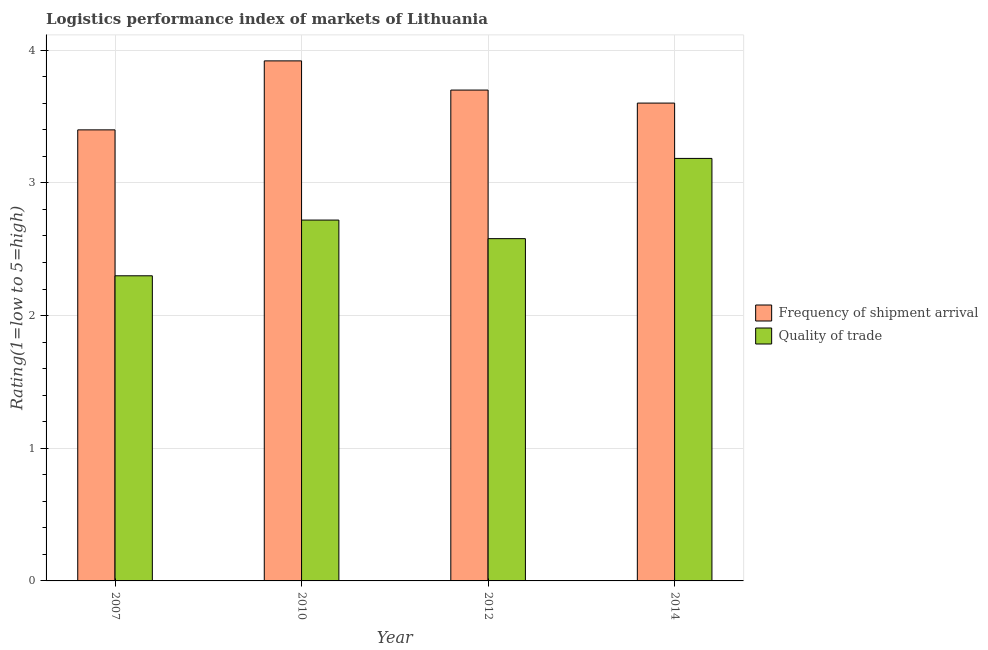How many different coloured bars are there?
Your response must be concise. 2. Are the number of bars per tick equal to the number of legend labels?
Give a very brief answer. Yes. Are the number of bars on each tick of the X-axis equal?
Offer a terse response. Yes. How many bars are there on the 1st tick from the left?
Offer a very short reply. 2. In how many cases, is the number of bars for a given year not equal to the number of legend labels?
Give a very brief answer. 0. What is the lpi of frequency of shipment arrival in 2012?
Your answer should be very brief. 3.7. Across all years, what is the maximum lpi of frequency of shipment arrival?
Keep it short and to the point. 3.92. Across all years, what is the minimum lpi of frequency of shipment arrival?
Your response must be concise. 3.4. In which year was the lpi quality of trade maximum?
Provide a short and direct response. 2014. In which year was the lpi of frequency of shipment arrival minimum?
Keep it short and to the point. 2007. What is the total lpi of frequency of shipment arrival in the graph?
Make the answer very short. 14.62. What is the difference between the lpi quality of trade in 2010 and that in 2012?
Keep it short and to the point. 0.14. What is the difference between the lpi of frequency of shipment arrival in 2014 and the lpi quality of trade in 2007?
Your response must be concise. 0.2. What is the average lpi of frequency of shipment arrival per year?
Your answer should be compact. 3.66. What is the ratio of the lpi quality of trade in 2007 to that in 2010?
Your answer should be compact. 0.85. Is the lpi quality of trade in 2010 less than that in 2012?
Ensure brevity in your answer.  No. What is the difference between the highest and the second highest lpi of frequency of shipment arrival?
Give a very brief answer. 0.22. What is the difference between the highest and the lowest lpi of frequency of shipment arrival?
Keep it short and to the point. 0.52. In how many years, is the lpi of frequency of shipment arrival greater than the average lpi of frequency of shipment arrival taken over all years?
Ensure brevity in your answer.  2. Is the sum of the lpi quality of trade in 2012 and 2014 greater than the maximum lpi of frequency of shipment arrival across all years?
Provide a succinct answer. Yes. What does the 1st bar from the left in 2012 represents?
Provide a succinct answer. Frequency of shipment arrival. What does the 1st bar from the right in 2007 represents?
Ensure brevity in your answer.  Quality of trade. Are all the bars in the graph horizontal?
Your answer should be very brief. No. How many years are there in the graph?
Offer a very short reply. 4. What is the difference between two consecutive major ticks on the Y-axis?
Offer a very short reply. 1. Are the values on the major ticks of Y-axis written in scientific E-notation?
Ensure brevity in your answer.  No. Does the graph contain grids?
Ensure brevity in your answer.  Yes. What is the title of the graph?
Provide a short and direct response. Logistics performance index of markets of Lithuania. What is the label or title of the Y-axis?
Offer a very short reply. Rating(1=low to 5=high). What is the Rating(1=low to 5=high) in Quality of trade in 2007?
Keep it short and to the point. 2.3. What is the Rating(1=low to 5=high) of Frequency of shipment arrival in 2010?
Your answer should be very brief. 3.92. What is the Rating(1=low to 5=high) in Quality of trade in 2010?
Give a very brief answer. 2.72. What is the Rating(1=low to 5=high) in Frequency of shipment arrival in 2012?
Your answer should be very brief. 3.7. What is the Rating(1=low to 5=high) in Quality of trade in 2012?
Offer a very short reply. 2.58. What is the Rating(1=low to 5=high) of Frequency of shipment arrival in 2014?
Give a very brief answer. 3.6. What is the Rating(1=low to 5=high) of Quality of trade in 2014?
Give a very brief answer. 3.18. Across all years, what is the maximum Rating(1=low to 5=high) of Frequency of shipment arrival?
Provide a succinct answer. 3.92. Across all years, what is the maximum Rating(1=low to 5=high) of Quality of trade?
Keep it short and to the point. 3.18. What is the total Rating(1=low to 5=high) of Frequency of shipment arrival in the graph?
Your answer should be very brief. 14.62. What is the total Rating(1=low to 5=high) in Quality of trade in the graph?
Your answer should be compact. 10.78. What is the difference between the Rating(1=low to 5=high) in Frequency of shipment arrival in 2007 and that in 2010?
Provide a short and direct response. -0.52. What is the difference between the Rating(1=low to 5=high) of Quality of trade in 2007 and that in 2010?
Your response must be concise. -0.42. What is the difference between the Rating(1=low to 5=high) of Frequency of shipment arrival in 2007 and that in 2012?
Make the answer very short. -0.3. What is the difference between the Rating(1=low to 5=high) of Quality of trade in 2007 and that in 2012?
Keep it short and to the point. -0.28. What is the difference between the Rating(1=low to 5=high) of Frequency of shipment arrival in 2007 and that in 2014?
Your answer should be very brief. -0.2. What is the difference between the Rating(1=low to 5=high) of Quality of trade in 2007 and that in 2014?
Make the answer very short. -0.88. What is the difference between the Rating(1=low to 5=high) of Frequency of shipment arrival in 2010 and that in 2012?
Ensure brevity in your answer.  0.22. What is the difference between the Rating(1=low to 5=high) of Quality of trade in 2010 and that in 2012?
Provide a short and direct response. 0.14. What is the difference between the Rating(1=low to 5=high) of Frequency of shipment arrival in 2010 and that in 2014?
Offer a terse response. 0.32. What is the difference between the Rating(1=low to 5=high) of Quality of trade in 2010 and that in 2014?
Give a very brief answer. -0.46. What is the difference between the Rating(1=low to 5=high) of Frequency of shipment arrival in 2012 and that in 2014?
Offer a very short reply. 0.1. What is the difference between the Rating(1=low to 5=high) of Quality of trade in 2012 and that in 2014?
Give a very brief answer. -0.6. What is the difference between the Rating(1=low to 5=high) of Frequency of shipment arrival in 2007 and the Rating(1=low to 5=high) of Quality of trade in 2010?
Your answer should be very brief. 0.68. What is the difference between the Rating(1=low to 5=high) in Frequency of shipment arrival in 2007 and the Rating(1=low to 5=high) in Quality of trade in 2012?
Keep it short and to the point. 0.82. What is the difference between the Rating(1=low to 5=high) in Frequency of shipment arrival in 2007 and the Rating(1=low to 5=high) in Quality of trade in 2014?
Provide a short and direct response. 0.22. What is the difference between the Rating(1=low to 5=high) of Frequency of shipment arrival in 2010 and the Rating(1=low to 5=high) of Quality of trade in 2012?
Provide a succinct answer. 1.34. What is the difference between the Rating(1=low to 5=high) in Frequency of shipment arrival in 2010 and the Rating(1=low to 5=high) in Quality of trade in 2014?
Provide a succinct answer. 0.74. What is the difference between the Rating(1=low to 5=high) of Frequency of shipment arrival in 2012 and the Rating(1=low to 5=high) of Quality of trade in 2014?
Your answer should be very brief. 0.52. What is the average Rating(1=low to 5=high) in Frequency of shipment arrival per year?
Keep it short and to the point. 3.66. What is the average Rating(1=low to 5=high) of Quality of trade per year?
Offer a terse response. 2.7. In the year 2007, what is the difference between the Rating(1=low to 5=high) of Frequency of shipment arrival and Rating(1=low to 5=high) of Quality of trade?
Your answer should be very brief. 1.1. In the year 2012, what is the difference between the Rating(1=low to 5=high) in Frequency of shipment arrival and Rating(1=low to 5=high) in Quality of trade?
Provide a succinct answer. 1.12. In the year 2014, what is the difference between the Rating(1=low to 5=high) in Frequency of shipment arrival and Rating(1=low to 5=high) in Quality of trade?
Your response must be concise. 0.42. What is the ratio of the Rating(1=low to 5=high) in Frequency of shipment arrival in 2007 to that in 2010?
Give a very brief answer. 0.87. What is the ratio of the Rating(1=low to 5=high) in Quality of trade in 2007 to that in 2010?
Keep it short and to the point. 0.85. What is the ratio of the Rating(1=low to 5=high) of Frequency of shipment arrival in 2007 to that in 2012?
Your answer should be compact. 0.92. What is the ratio of the Rating(1=low to 5=high) of Quality of trade in 2007 to that in 2012?
Offer a very short reply. 0.89. What is the ratio of the Rating(1=low to 5=high) of Frequency of shipment arrival in 2007 to that in 2014?
Make the answer very short. 0.94. What is the ratio of the Rating(1=low to 5=high) in Quality of trade in 2007 to that in 2014?
Provide a short and direct response. 0.72. What is the ratio of the Rating(1=low to 5=high) of Frequency of shipment arrival in 2010 to that in 2012?
Offer a very short reply. 1.06. What is the ratio of the Rating(1=low to 5=high) in Quality of trade in 2010 to that in 2012?
Your answer should be compact. 1.05. What is the ratio of the Rating(1=low to 5=high) in Frequency of shipment arrival in 2010 to that in 2014?
Ensure brevity in your answer.  1.09. What is the ratio of the Rating(1=low to 5=high) in Quality of trade in 2010 to that in 2014?
Provide a short and direct response. 0.85. What is the ratio of the Rating(1=low to 5=high) of Frequency of shipment arrival in 2012 to that in 2014?
Your response must be concise. 1.03. What is the ratio of the Rating(1=low to 5=high) in Quality of trade in 2012 to that in 2014?
Ensure brevity in your answer.  0.81. What is the difference between the highest and the second highest Rating(1=low to 5=high) of Frequency of shipment arrival?
Ensure brevity in your answer.  0.22. What is the difference between the highest and the second highest Rating(1=low to 5=high) in Quality of trade?
Your response must be concise. 0.46. What is the difference between the highest and the lowest Rating(1=low to 5=high) of Frequency of shipment arrival?
Offer a very short reply. 0.52. What is the difference between the highest and the lowest Rating(1=low to 5=high) of Quality of trade?
Offer a very short reply. 0.88. 